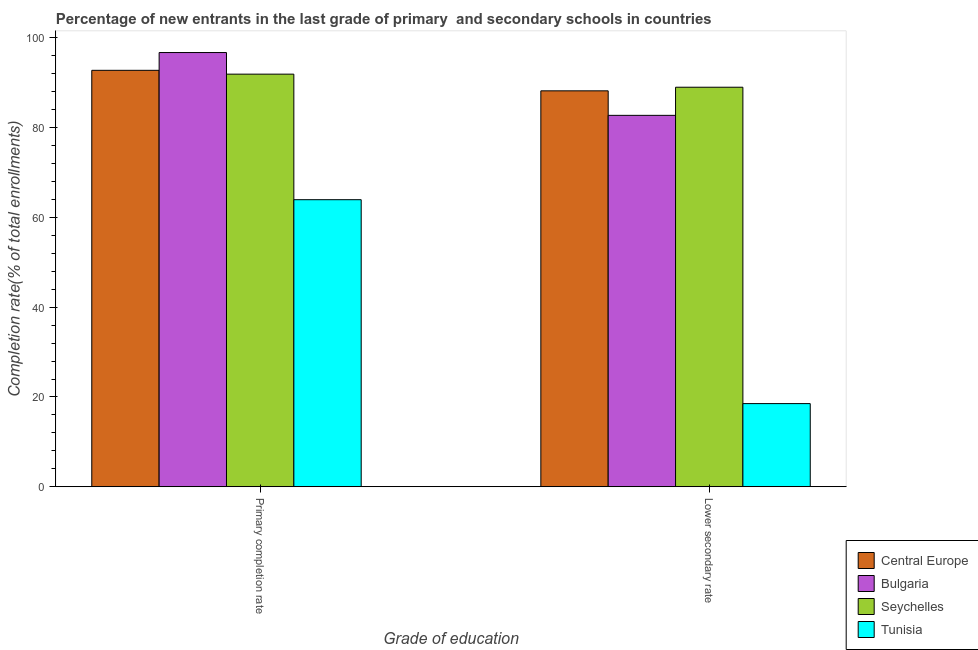How many different coloured bars are there?
Offer a terse response. 4. How many groups of bars are there?
Your answer should be very brief. 2. How many bars are there on the 1st tick from the left?
Give a very brief answer. 4. What is the label of the 2nd group of bars from the left?
Provide a succinct answer. Lower secondary rate. What is the completion rate in secondary schools in Seychelles?
Provide a succinct answer. 89.03. Across all countries, what is the maximum completion rate in secondary schools?
Ensure brevity in your answer.  89.03. Across all countries, what is the minimum completion rate in primary schools?
Provide a succinct answer. 63.96. In which country was the completion rate in secondary schools maximum?
Your response must be concise. Seychelles. In which country was the completion rate in secondary schools minimum?
Offer a terse response. Tunisia. What is the total completion rate in primary schools in the graph?
Keep it short and to the point. 345.45. What is the difference between the completion rate in primary schools in Bulgaria and that in Central Europe?
Offer a terse response. 3.97. What is the difference between the completion rate in primary schools in Central Europe and the completion rate in secondary schools in Tunisia?
Ensure brevity in your answer.  74.27. What is the average completion rate in primary schools per country?
Keep it short and to the point. 86.36. What is the difference between the completion rate in primary schools and completion rate in secondary schools in Seychelles?
Make the answer very short. 2.91. In how many countries, is the completion rate in secondary schools greater than 52 %?
Make the answer very short. 3. What is the ratio of the completion rate in secondary schools in Central Europe to that in Bulgaria?
Give a very brief answer. 1.07. In how many countries, is the completion rate in primary schools greater than the average completion rate in primary schools taken over all countries?
Ensure brevity in your answer.  3. What does the 3rd bar from the left in Lower secondary rate represents?
Provide a succinct answer. Seychelles. What does the 4th bar from the right in Lower secondary rate represents?
Offer a terse response. Central Europe. How many bars are there?
Your answer should be very brief. 8. Are all the bars in the graph horizontal?
Your answer should be compact. No. How many countries are there in the graph?
Give a very brief answer. 4. How many legend labels are there?
Offer a terse response. 4. How are the legend labels stacked?
Provide a succinct answer. Vertical. What is the title of the graph?
Keep it short and to the point. Percentage of new entrants in the last grade of primary  and secondary schools in countries. What is the label or title of the X-axis?
Provide a short and direct response. Grade of education. What is the label or title of the Y-axis?
Give a very brief answer. Completion rate(% of total enrollments). What is the Completion rate(% of total enrollments) of Central Europe in Primary completion rate?
Make the answer very short. 92.79. What is the Completion rate(% of total enrollments) in Bulgaria in Primary completion rate?
Ensure brevity in your answer.  96.76. What is the Completion rate(% of total enrollments) in Seychelles in Primary completion rate?
Provide a succinct answer. 91.94. What is the Completion rate(% of total enrollments) in Tunisia in Primary completion rate?
Give a very brief answer. 63.96. What is the Completion rate(% of total enrollments) in Central Europe in Lower secondary rate?
Provide a short and direct response. 88.22. What is the Completion rate(% of total enrollments) in Bulgaria in Lower secondary rate?
Your response must be concise. 82.76. What is the Completion rate(% of total enrollments) of Seychelles in Lower secondary rate?
Give a very brief answer. 89.03. What is the Completion rate(% of total enrollments) of Tunisia in Lower secondary rate?
Your answer should be compact. 18.52. Across all Grade of education, what is the maximum Completion rate(% of total enrollments) of Central Europe?
Ensure brevity in your answer.  92.79. Across all Grade of education, what is the maximum Completion rate(% of total enrollments) of Bulgaria?
Offer a terse response. 96.76. Across all Grade of education, what is the maximum Completion rate(% of total enrollments) in Seychelles?
Your answer should be compact. 91.94. Across all Grade of education, what is the maximum Completion rate(% of total enrollments) of Tunisia?
Make the answer very short. 63.96. Across all Grade of education, what is the minimum Completion rate(% of total enrollments) of Central Europe?
Keep it short and to the point. 88.22. Across all Grade of education, what is the minimum Completion rate(% of total enrollments) of Bulgaria?
Ensure brevity in your answer.  82.76. Across all Grade of education, what is the minimum Completion rate(% of total enrollments) of Seychelles?
Give a very brief answer. 89.03. Across all Grade of education, what is the minimum Completion rate(% of total enrollments) in Tunisia?
Offer a very short reply. 18.52. What is the total Completion rate(% of total enrollments) of Central Europe in the graph?
Provide a short and direct response. 181.02. What is the total Completion rate(% of total enrollments) of Bulgaria in the graph?
Make the answer very short. 179.52. What is the total Completion rate(% of total enrollments) of Seychelles in the graph?
Keep it short and to the point. 180.97. What is the total Completion rate(% of total enrollments) in Tunisia in the graph?
Give a very brief answer. 82.49. What is the difference between the Completion rate(% of total enrollments) in Central Europe in Primary completion rate and that in Lower secondary rate?
Ensure brevity in your answer.  4.57. What is the difference between the Completion rate(% of total enrollments) of Bulgaria in Primary completion rate and that in Lower secondary rate?
Ensure brevity in your answer.  14. What is the difference between the Completion rate(% of total enrollments) in Seychelles in Primary completion rate and that in Lower secondary rate?
Your answer should be compact. 2.91. What is the difference between the Completion rate(% of total enrollments) of Tunisia in Primary completion rate and that in Lower secondary rate?
Ensure brevity in your answer.  45.44. What is the difference between the Completion rate(% of total enrollments) in Central Europe in Primary completion rate and the Completion rate(% of total enrollments) in Bulgaria in Lower secondary rate?
Provide a succinct answer. 10.03. What is the difference between the Completion rate(% of total enrollments) in Central Europe in Primary completion rate and the Completion rate(% of total enrollments) in Seychelles in Lower secondary rate?
Offer a terse response. 3.77. What is the difference between the Completion rate(% of total enrollments) in Central Europe in Primary completion rate and the Completion rate(% of total enrollments) in Tunisia in Lower secondary rate?
Make the answer very short. 74.27. What is the difference between the Completion rate(% of total enrollments) of Bulgaria in Primary completion rate and the Completion rate(% of total enrollments) of Seychelles in Lower secondary rate?
Offer a very short reply. 7.73. What is the difference between the Completion rate(% of total enrollments) of Bulgaria in Primary completion rate and the Completion rate(% of total enrollments) of Tunisia in Lower secondary rate?
Make the answer very short. 78.23. What is the difference between the Completion rate(% of total enrollments) in Seychelles in Primary completion rate and the Completion rate(% of total enrollments) in Tunisia in Lower secondary rate?
Ensure brevity in your answer.  73.42. What is the average Completion rate(% of total enrollments) in Central Europe per Grade of education?
Keep it short and to the point. 90.51. What is the average Completion rate(% of total enrollments) of Bulgaria per Grade of education?
Your response must be concise. 89.76. What is the average Completion rate(% of total enrollments) in Seychelles per Grade of education?
Ensure brevity in your answer.  90.48. What is the average Completion rate(% of total enrollments) in Tunisia per Grade of education?
Your answer should be very brief. 41.24. What is the difference between the Completion rate(% of total enrollments) in Central Europe and Completion rate(% of total enrollments) in Bulgaria in Primary completion rate?
Your answer should be compact. -3.97. What is the difference between the Completion rate(% of total enrollments) in Central Europe and Completion rate(% of total enrollments) in Seychelles in Primary completion rate?
Give a very brief answer. 0.85. What is the difference between the Completion rate(% of total enrollments) in Central Europe and Completion rate(% of total enrollments) in Tunisia in Primary completion rate?
Offer a very short reply. 28.83. What is the difference between the Completion rate(% of total enrollments) of Bulgaria and Completion rate(% of total enrollments) of Seychelles in Primary completion rate?
Provide a succinct answer. 4.82. What is the difference between the Completion rate(% of total enrollments) of Bulgaria and Completion rate(% of total enrollments) of Tunisia in Primary completion rate?
Your answer should be very brief. 32.8. What is the difference between the Completion rate(% of total enrollments) in Seychelles and Completion rate(% of total enrollments) in Tunisia in Primary completion rate?
Ensure brevity in your answer.  27.98. What is the difference between the Completion rate(% of total enrollments) in Central Europe and Completion rate(% of total enrollments) in Bulgaria in Lower secondary rate?
Your answer should be very brief. 5.46. What is the difference between the Completion rate(% of total enrollments) in Central Europe and Completion rate(% of total enrollments) in Seychelles in Lower secondary rate?
Give a very brief answer. -0.8. What is the difference between the Completion rate(% of total enrollments) of Central Europe and Completion rate(% of total enrollments) of Tunisia in Lower secondary rate?
Your answer should be compact. 69.7. What is the difference between the Completion rate(% of total enrollments) in Bulgaria and Completion rate(% of total enrollments) in Seychelles in Lower secondary rate?
Offer a very short reply. -6.27. What is the difference between the Completion rate(% of total enrollments) of Bulgaria and Completion rate(% of total enrollments) of Tunisia in Lower secondary rate?
Your answer should be compact. 64.24. What is the difference between the Completion rate(% of total enrollments) in Seychelles and Completion rate(% of total enrollments) in Tunisia in Lower secondary rate?
Keep it short and to the point. 70.5. What is the ratio of the Completion rate(% of total enrollments) in Central Europe in Primary completion rate to that in Lower secondary rate?
Ensure brevity in your answer.  1.05. What is the ratio of the Completion rate(% of total enrollments) of Bulgaria in Primary completion rate to that in Lower secondary rate?
Your answer should be compact. 1.17. What is the ratio of the Completion rate(% of total enrollments) in Seychelles in Primary completion rate to that in Lower secondary rate?
Your response must be concise. 1.03. What is the ratio of the Completion rate(% of total enrollments) in Tunisia in Primary completion rate to that in Lower secondary rate?
Make the answer very short. 3.45. What is the difference between the highest and the second highest Completion rate(% of total enrollments) in Central Europe?
Keep it short and to the point. 4.57. What is the difference between the highest and the second highest Completion rate(% of total enrollments) in Bulgaria?
Give a very brief answer. 14. What is the difference between the highest and the second highest Completion rate(% of total enrollments) of Seychelles?
Provide a succinct answer. 2.91. What is the difference between the highest and the second highest Completion rate(% of total enrollments) of Tunisia?
Ensure brevity in your answer.  45.44. What is the difference between the highest and the lowest Completion rate(% of total enrollments) in Central Europe?
Your answer should be compact. 4.57. What is the difference between the highest and the lowest Completion rate(% of total enrollments) of Bulgaria?
Your response must be concise. 14. What is the difference between the highest and the lowest Completion rate(% of total enrollments) in Seychelles?
Ensure brevity in your answer.  2.91. What is the difference between the highest and the lowest Completion rate(% of total enrollments) of Tunisia?
Offer a very short reply. 45.44. 